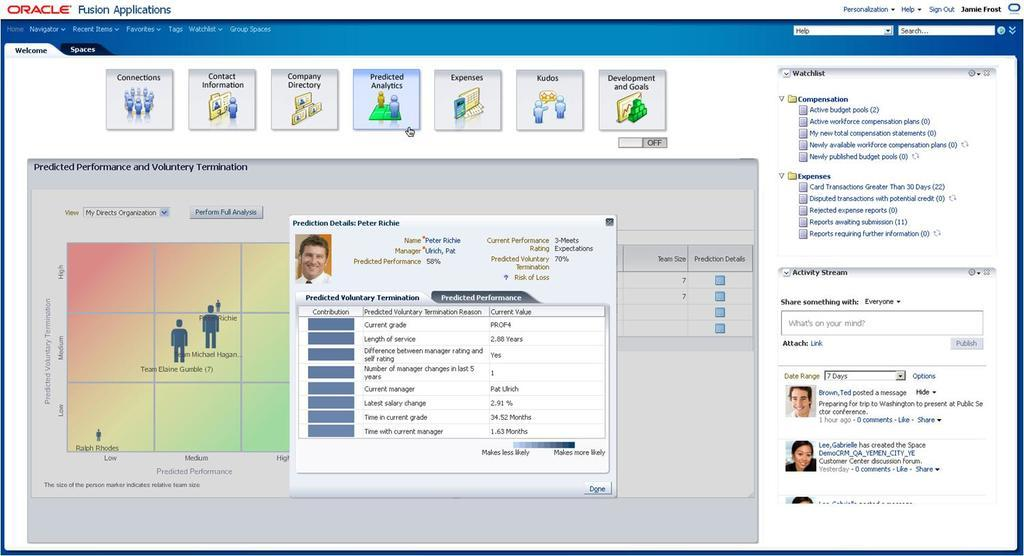What type of document is shown in the image? The image is of an oracle page. What can be found on the oracle page besides text? There are logos and pictures on the oracle page. Can you describe the content of the oracle page? The oracle page contains text, logos, and pictures. What type of protest is depicted in the image? There is no protest depicted in the image; it is an oracle page with logos, text, and pictures. How many ducks are visible in the image? There are no ducks present in the image. 